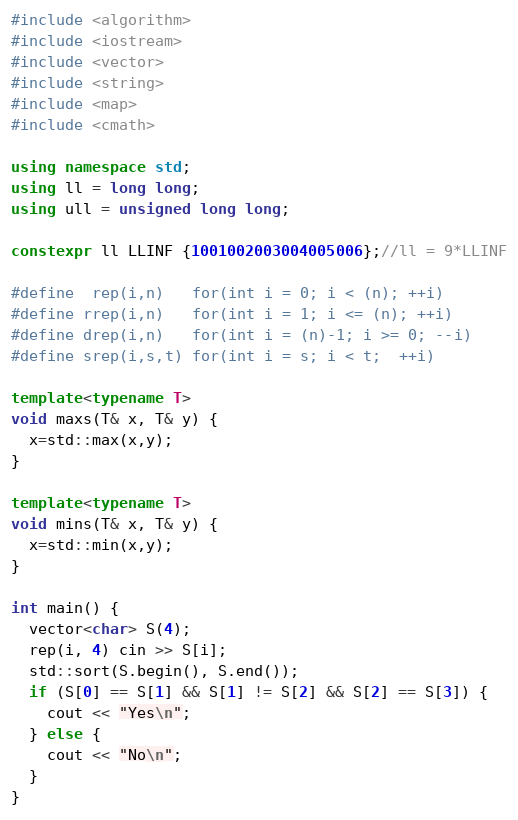Convert code to text. <code><loc_0><loc_0><loc_500><loc_500><_C++_>#include <algorithm>
#include <iostream>
#include <vector>
#include <string>
#include <map>
#include <cmath>

using namespace std;
using ll = long long;
using ull = unsigned long long;

constexpr ll LLINF {1001002003004005006};//ll = 9*LLINF

#define  rep(i,n)   for(int i = 0; i < (n); ++i)
#define rrep(i,n)   for(int i = 1; i <= (n); ++i)
#define drep(i,n)   for(int i = (n)-1; i >= 0; --i)
#define srep(i,s,t) for(int i = s; i < t;  ++i)

template<typename T>
void maxs(T& x, T& y) {
  x=std::max(x,y);
}

template<typename T>
void mins(T& x, T& y) {
  x=std::min(x,y);
}

int main() {
  vector<char> S(4);
  rep(i, 4) cin >> S[i];
  std::sort(S.begin(), S.end());
  if (S[0] == S[1] && S[1] != S[2] && S[2] == S[3]) {
    cout << "Yes\n";
  } else {
    cout << "No\n";
  }
}
</code> 